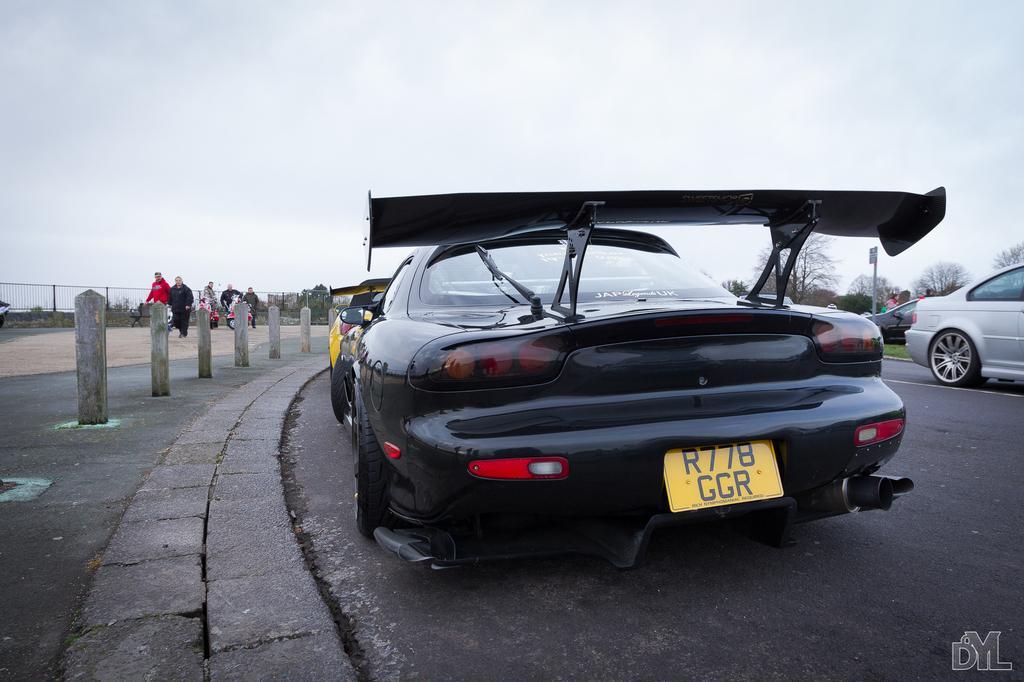How would you summarize this image in a sentence or two? In the picture I can see the cars on the road. I can see the poles on the side of the road on the left side. I can see a few persons on the left side. In the background, I can see the metal fence and trees. 